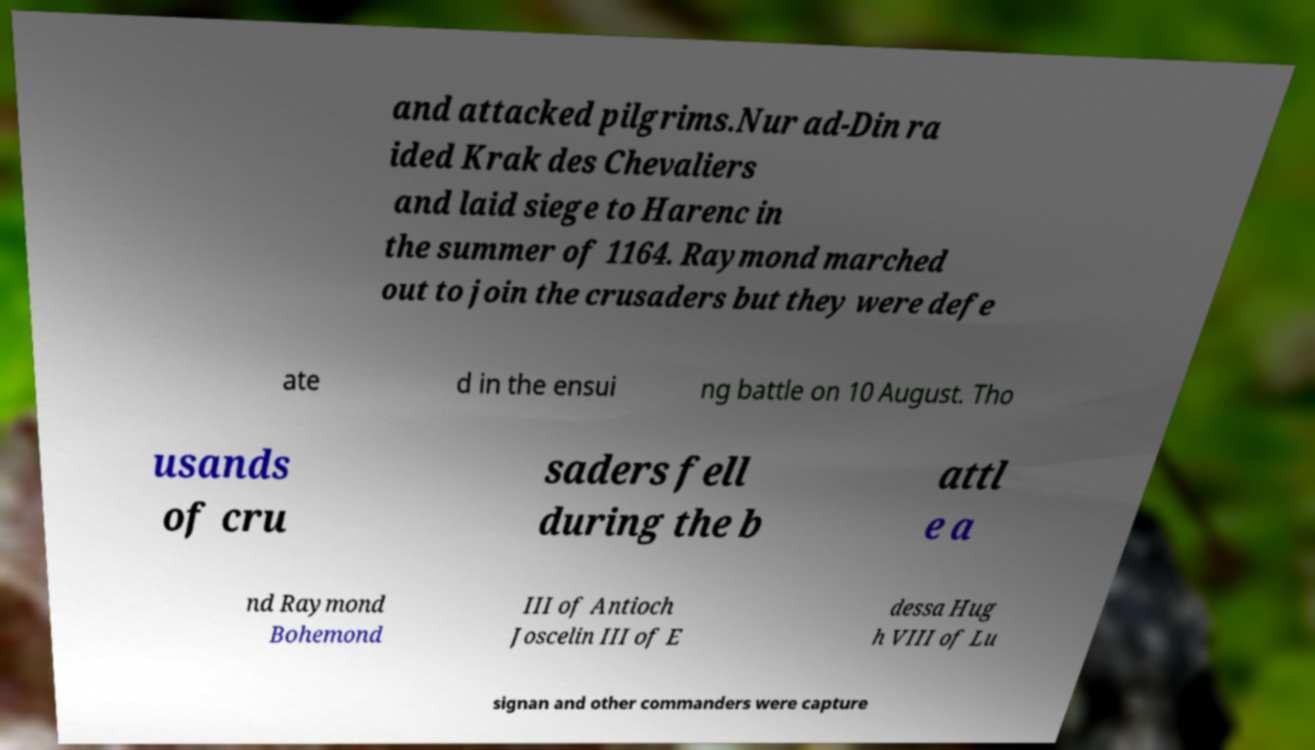Could you assist in decoding the text presented in this image and type it out clearly? and attacked pilgrims.Nur ad-Din ra ided Krak des Chevaliers and laid siege to Harenc in the summer of 1164. Raymond marched out to join the crusaders but they were defe ate d in the ensui ng battle on 10 August. Tho usands of cru saders fell during the b attl e a nd Raymond Bohemond III of Antioch Joscelin III of E dessa Hug h VIII of Lu signan and other commanders were capture 